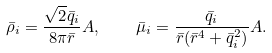<formula> <loc_0><loc_0><loc_500><loc_500>\bar { \rho } _ { i } = \frac { { \sqrt { 2 } \bar { q } _ { i } } } { 8 \pi \bar { r } } A , \quad \bar { \mu } _ { i } = \frac { \bar { q } _ { i } } { \bar { r } ( \bar { r } ^ { 4 } + \bar { q } _ { i } ^ { 2 } ) } A .</formula> 